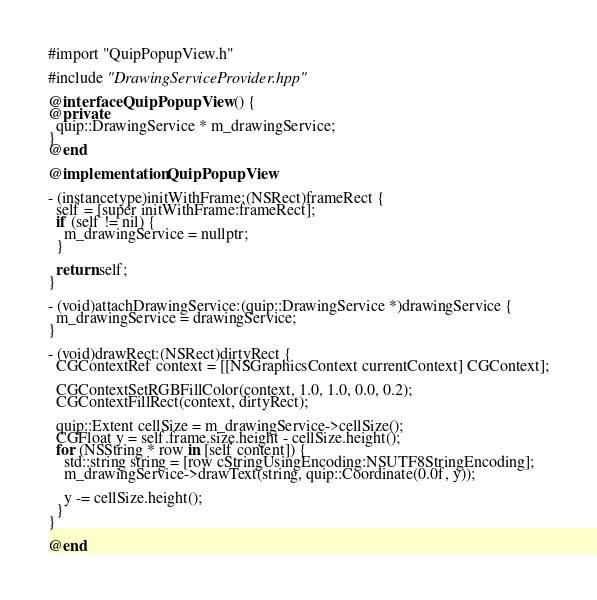<code> <loc_0><loc_0><loc_500><loc_500><_ObjectiveC_>#import "QuipPopupView.h"

#include "DrawingServiceProvider.hpp"

@interface QuipPopupView () {
@private
  quip::DrawingService * m_drawingService;
}
@end

@implementation QuipPopupView

- (instancetype)initWithFrame:(NSRect)frameRect {
  self = [super initWithFrame:frameRect];
  if (self != nil) {
    m_drawingService = nullptr;
  }
  
  return self;
}

- (void)attachDrawingService:(quip::DrawingService *)drawingService {
  m_drawingService = drawingService;
}

- (void)drawRect:(NSRect)dirtyRect {
  CGContextRef context = [[NSGraphicsContext currentContext] CGContext];

  CGContextSetRGBFillColor(context, 1.0, 1.0, 0.0, 0.2);
  CGContextFillRect(context, dirtyRect);
  
  quip::Extent cellSize = m_drawingService->cellSize();
  CGFloat y = self.frame.size.height - cellSize.height();
  for (NSString * row in [self content]) {
    std::string string = [row cStringUsingEncoding:NSUTF8StringEncoding];
    m_drawingService->drawText(string, quip::Coordinate(0.0f, y));
    
    y -= cellSize.height();
  }
}

@end
</code> 